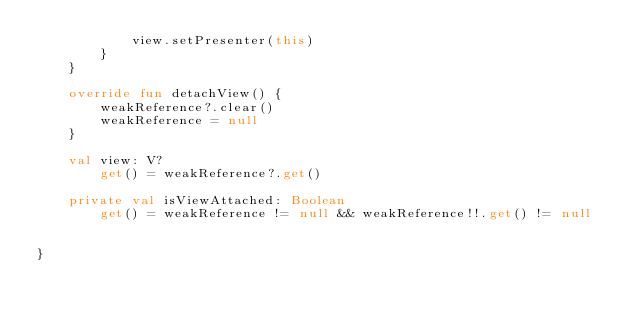<code> <loc_0><loc_0><loc_500><loc_500><_Kotlin_>            view.setPresenter(this)
        }
    }

    override fun detachView() {
        weakReference?.clear()
        weakReference = null
    }

    val view: V?
        get() = weakReference?.get()

    private val isViewAttached: Boolean
        get() = weakReference != null && weakReference!!.get() != null


}
</code> 